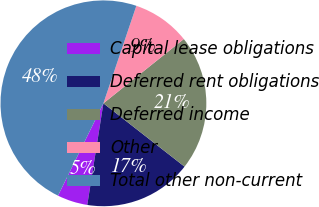Convert chart. <chart><loc_0><loc_0><loc_500><loc_500><pie_chart><fcel>Capital lease obligations<fcel>Deferred rent obligations<fcel>Deferred income<fcel>Other<fcel>Total other non-current<nl><fcel>4.77%<fcel>16.96%<fcel>21.28%<fcel>9.08%<fcel>47.91%<nl></chart> 